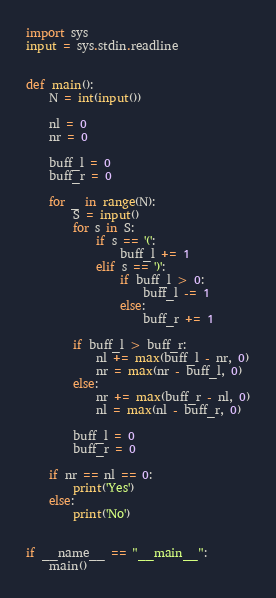Convert code to text. <code><loc_0><loc_0><loc_500><loc_500><_Python_>import sys
input = sys.stdin.readline


def main():
    N = int(input())

    nl = 0
    nr = 0

    buff_l = 0
    buff_r = 0

    for _ in range(N):
        S = input()
        for s in S:
            if s == '(':
                buff_l += 1
            elif s == ')':
                if buff_l > 0:
                    buff_l -= 1
                else:
                    buff_r += 1

        if buff_l > buff_r:
            nl += max(buff_l - nr, 0)
            nr = max(nr - buff_l, 0)
        else:
            nr += max(buff_r - nl, 0)
            nl = max(nl - buff_r, 0)

        buff_l = 0
        buff_r = 0

    if nr == nl == 0:
        print('Yes')
    else:
        print('No')


if __name__ == "__main__":
    main()
</code> 